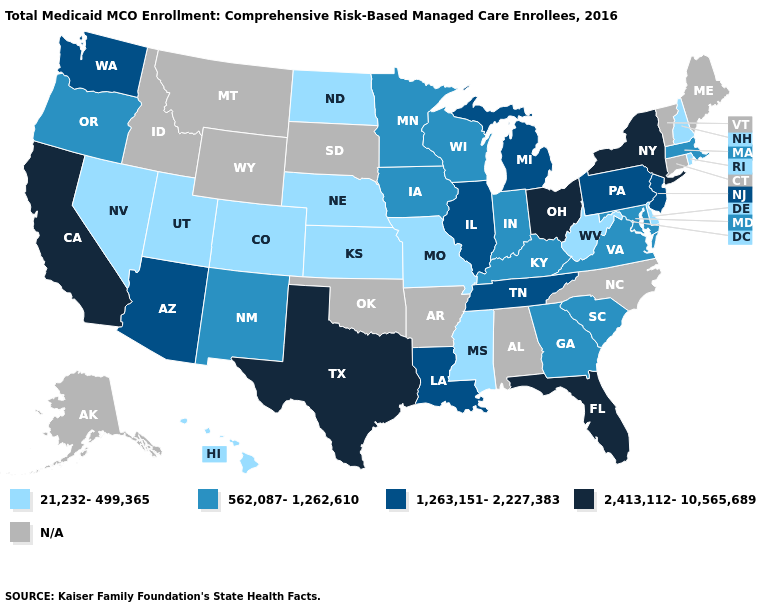Does Mississippi have the lowest value in the USA?
Quick response, please. Yes. Does West Virginia have the lowest value in the South?
Give a very brief answer. Yes. What is the highest value in the USA?
Be succinct. 2,413,112-10,565,689. How many symbols are there in the legend?
Be succinct. 5. What is the value of Idaho?
Quick response, please. N/A. What is the value of Oklahoma?
Answer briefly. N/A. Name the states that have a value in the range 21,232-499,365?
Concise answer only. Colorado, Delaware, Hawaii, Kansas, Mississippi, Missouri, Nebraska, Nevada, New Hampshire, North Dakota, Rhode Island, Utah, West Virginia. Does West Virginia have the lowest value in the USA?
Write a very short answer. Yes. What is the value of Arkansas?
Be succinct. N/A. Name the states that have a value in the range 562,087-1,262,610?
Write a very short answer. Georgia, Indiana, Iowa, Kentucky, Maryland, Massachusetts, Minnesota, New Mexico, Oregon, South Carolina, Virginia, Wisconsin. Does West Virginia have the lowest value in the South?
Give a very brief answer. Yes. Is the legend a continuous bar?
Keep it brief. No. What is the value of Wyoming?
Answer briefly. N/A. 